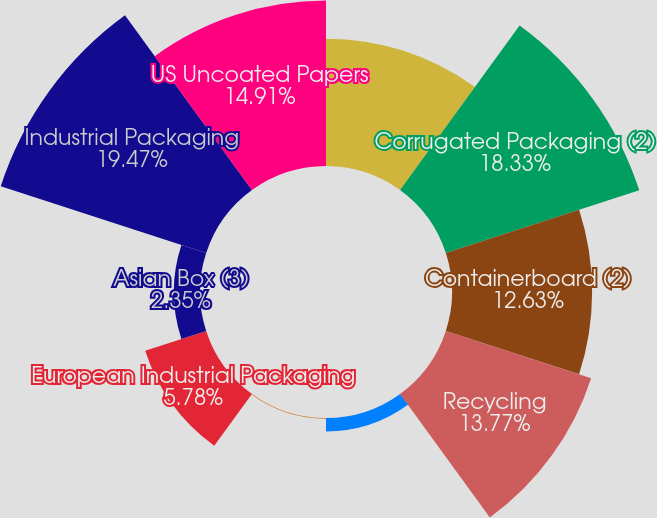Convert chart. <chart><loc_0><loc_0><loc_500><loc_500><pie_chart><fcel>In thousands of short tons<fcel>Corrugated Packaging (2)<fcel>Containerboard (2)<fcel>Recycling<fcel>Saturated Kraft<fcel>Bleached Kraft<fcel>European Industrial Packaging<fcel>Asian Box (3)<fcel>Industrial Packaging<fcel>US Uncoated Papers<nl><fcel>11.48%<fcel>18.33%<fcel>12.63%<fcel>13.77%<fcel>1.21%<fcel>0.07%<fcel>5.78%<fcel>2.35%<fcel>19.47%<fcel>14.91%<nl></chart> 